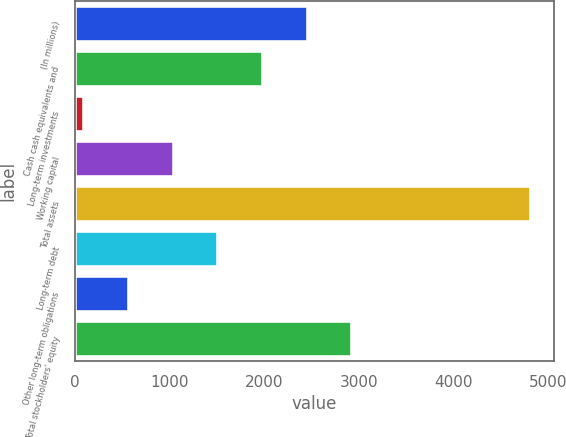Convert chart. <chart><loc_0><loc_0><loc_500><loc_500><bar_chart><fcel>(In millions)<fcel>Cash cash equivalents and<fcel>Long-term investments<fcel>Working capital<fcel>Total assets<fcel>Long-term debt<fcel>Other long-term obligations<fcel>Total stockholders' equity<nl><fcel>2461.5<fcel>1988.6<fcel>97<fcel>1042.8<fcel>4826<fcel>1515.7<fcel>569.9<fcel>2934.4<nl></chart> 